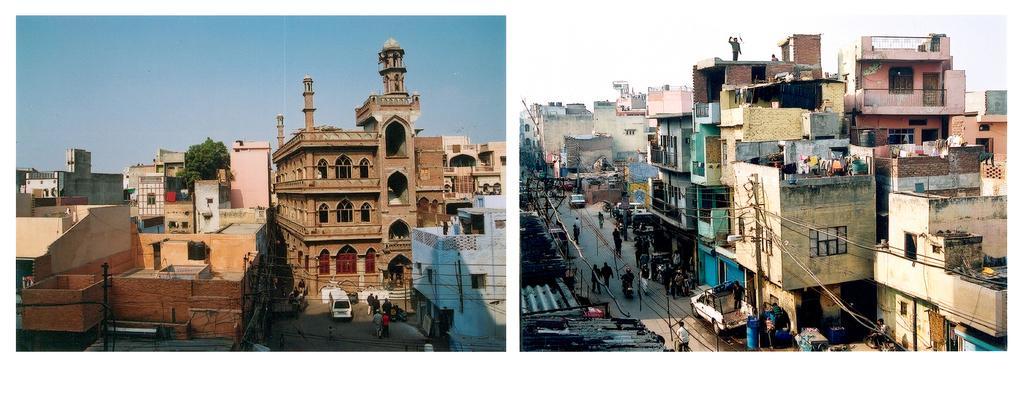How would you summarize this image in a sentence or two? The image consists of two pictures. In both of them there are building. On the road there are vehicles, people. The sky is clear. Here there is a tree. 